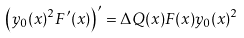<formula> <loc_0><loc_0><loc_500><loc_500>\left ( y _ { 0 } ( x ) ^ { 2 } F ^ { \prime } ( x ) \right ) ^ { \prime } = \Delta Q ( x ) F ( x ) y _ { 0 } ( x ) ^ { 2 }</formula> 